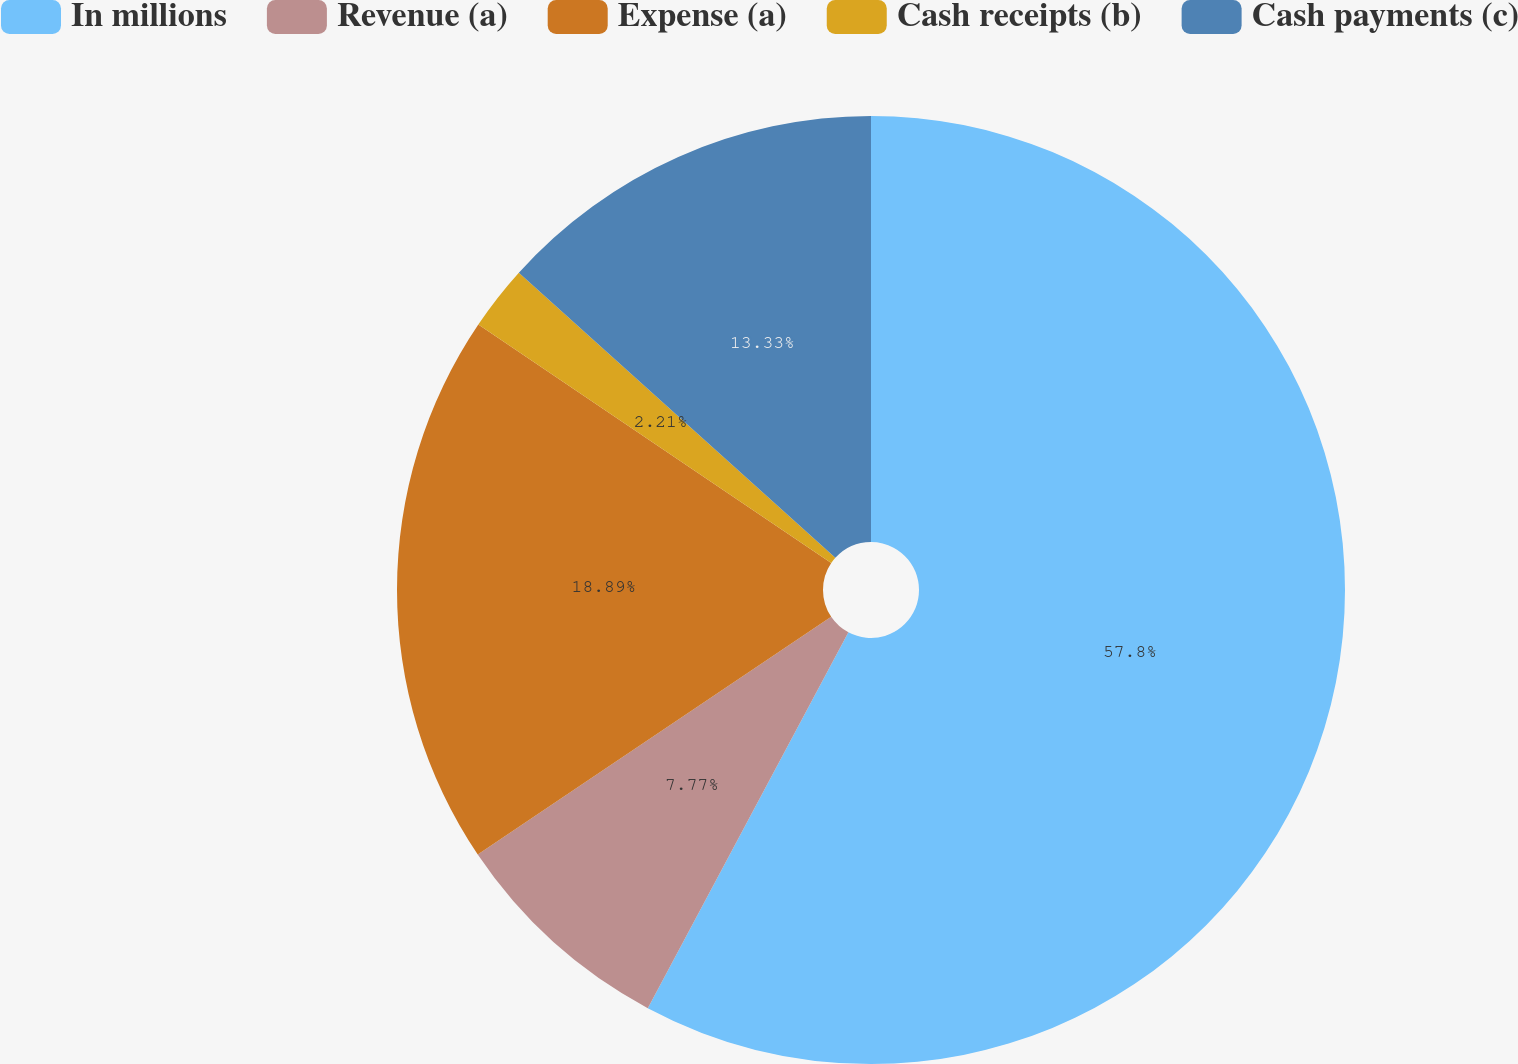<chart> <loc_0><loc_0><loc_500><loc_500><pie_chart><fcel>In millions<fcel>Revenue (a)<fcel>Expense (a)<fcel>Cash receipts (b)<fcel>Cash payments (c)<nl><fcel>57.81%<fcel>7.77%<fcel>18.89%<fcel>2.21%<fcel>13.33%<nl></chart> 